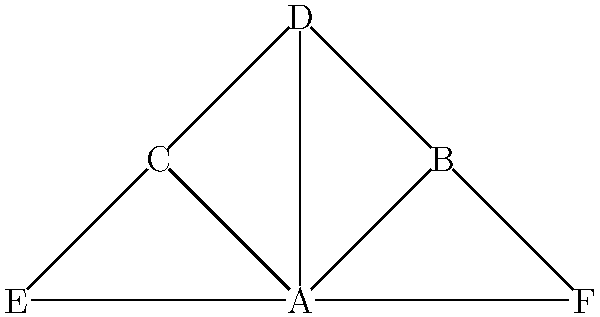In the given network diagram representing team members and their connections, which team member acts as the central hub for communication and collaboration? How many direct connections does this central member have, and what implications might this have for team dynamics and information flow? To answer this question, we need to analyze the network diagram step-by-step:

1. Identify the central node:
   - Node A is connected to all other nodes in the network.
   - No other node has as many connections as A.

2. Count direct connections for the central node:
   - Node A is directly connected to nodes B, C, D, E, and F.
   - The total number of direct connections for A is 5.

3. Implications for team dynamics and information flow:
   a) Centralization: 
      - Member A is in a position to facilitate communication between all team members.
      - This centralization can lead to efficient information sharing but may also create a bottleneck.

   b) Dependency:
      - Other team members rely heavily on A for information and coordination.
      - This dependency might lead to vulnerability if A is unavailable or overwhelmed.

   c) Workload distribution:
      - A may experience a higher workload due to managing multiple connections.
      - This could lead to stress or burnout for A if not managed properly.

   d) Power dynamics:
      - A's central position might result in more influence or decision-making power.
      - This could be beneficial for leadership but may also create power imbalances.

   e) Information flow:
      - Information can quickly spread through the network via A.
      - However, there's a risk of information distortion or filtering through a single point.

   f) Team cohesion:
      - A's connections can help maintain overall team cohesion.
      - But it may also limit direct interactions between other team members.

   g) Adaptability:
      - The team's structure allows for quick dissemination of information.
      - However, it may be less resilient to changes or absence of the central member.

Understanding these implications is crucial for optimizing team performance and addressing potential challenges in the group's dynamics.
Answer: Member A; 5 connections; centralized communication, efficient but potentially bottlenecked information flow, high dependency on central member. 